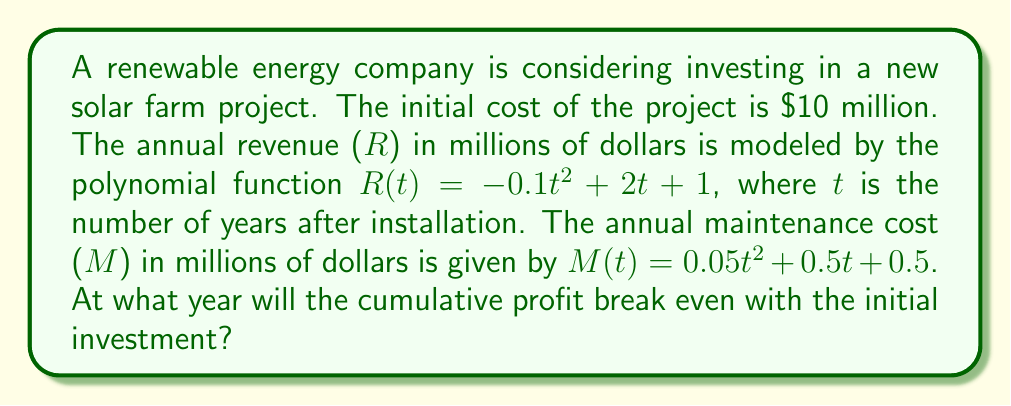What is the answer to this math problem? To solve this problem, we need to follow these steps:

1) First, let's define the annual profit function P(t):
   $P(t) = R(t) - M(t)$
   $P(t) = (-0.1t^2 + 2t + 1) - (0.05t^2 + 0.5t + 0.5)$
   $P(t) = -0.15t^2 + 1.5t + 0.5$

2) Now, we need to find the cumulative profit function C(t):
   $C(t) = \int_0^t P(x) dx$
   $C(t) = \int_0^t (-0.15x^2 + 1.5x + 0.5) dx$
   $C(t) = [-0.05x^3 + 0.75x^2 + 0.5x]_0^t$
   $C(t) = -0.05t^3 + 0.75t^2 + 0.5t$

3) The break-even point occurs when the cumulative profit equals the initial investment:
   $C(t) = 10$
   $-0.05t^3 + 0.75t^2 + 0.5t = 10$

4) Rearrange the equation:
   $-0.05t^3 + 0.75t^2 + 0.5t - 10 = 0$

5) This cubic equation doesn't have a simple analytical solution. We need to use numerical methods or graphing to find the solution.

6) Using a graphing calculator or computer software, we can find that the equation has one real root at approximately t = 6.76 years.

Therefore, the project will break even after approximately 6.76 years.
Answer: 6.76 years 